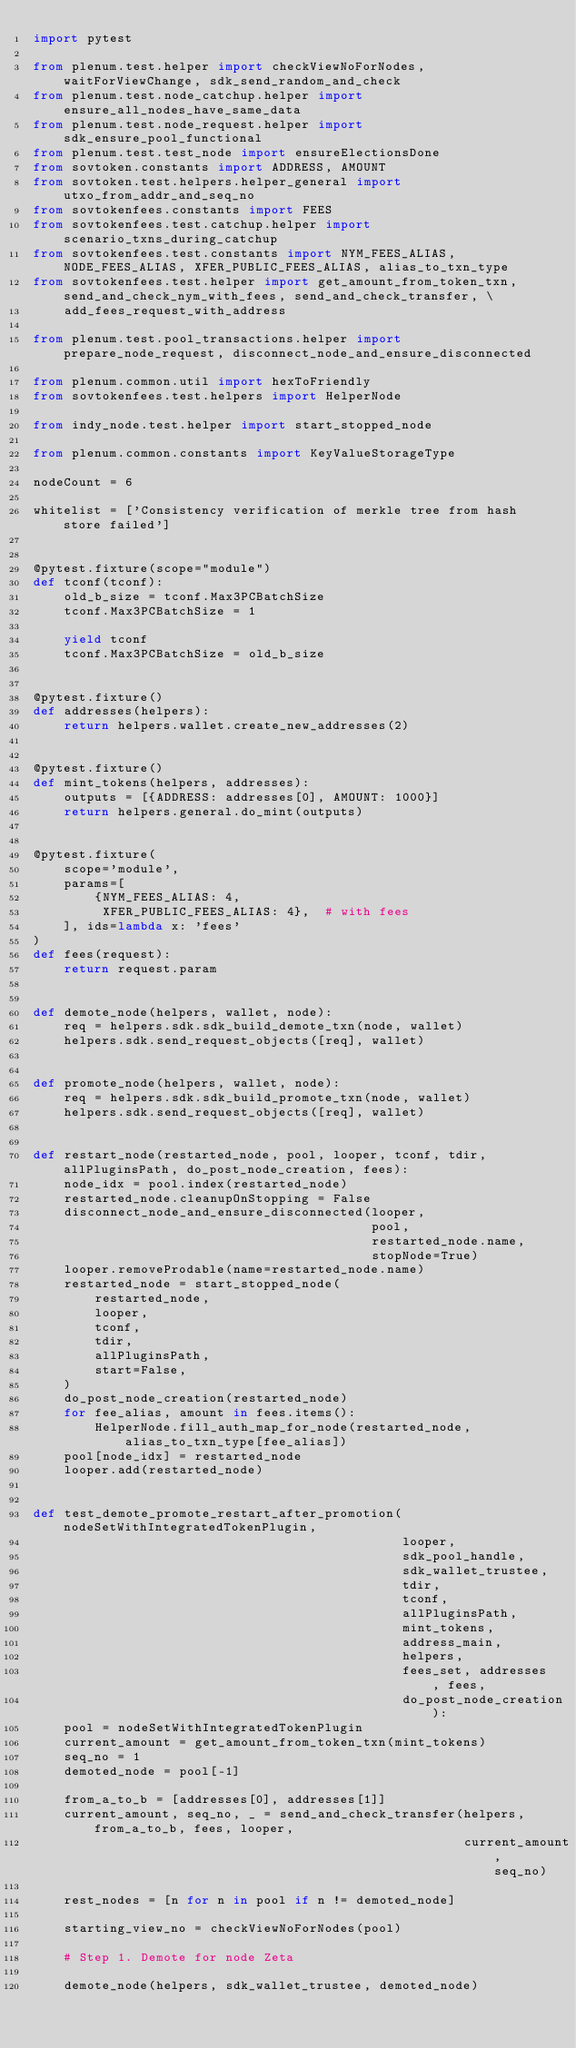<code> <loc_0><loc_0><loc_500><loc_500><_Python_>import pytest

from plenum.test.helper import checkViewNoForNodes, waitForViewChange, sdk_send_random_and_check
from plenum.test.node_catchup.helper import ensure_all_nodes_have_same_data
from plenum.test.node_request.helper import sdk_ensure_pool_functional
from plenum.test.test_node import ensureElectionsDone
from sovtoken.constants import ADDRESS, AMOUNT
from sovtoken.test.helpers.helper_general import utxo_from_addr_and_seq_no
from sovtokenfees.constants import FEES
from sovtokenfees.test.catchup.helper import scenario_txns_during_catchup
from sovtokenfees.test.constants import NYM_FEES_ALIAS, NODE_FEES_ALIAS, XFER_PUBLIC_FEES_ALIAS, alias_to_txn_type
from sovtokenfees.test.helper import get_amount_from_token_txn, send_and_check_nym_with_fees, send_and_check_transfer, \
    add_fees_request_with_address

from plenum.test.pool_transactions.helper import prepare_node_request, disconnect_node_and_ensure_disconnected

from plenum.common.util import hexToFriendly
from sovtokenfees.test.helpers import HelperNode

from indy_node.test.helper import start_stopped_node

from plenum.common.constants import KeyValueStorageType

nodeCount = 6

whitelist = ['Consistency verification of merkle tree from hash store failed']


@pytest.fixture(scope="module")
def tconf(tconf):
    old_b_size = tconf.Max3PCBatchSize
    tconf.Max3PCBatchSize = 1

    yield tconf
    tconf.Max3PCBatchSize = old_b_size


@pytest.fixture()
def addresses(helpers):
    return helpers.wallet.create_new_addresses(2)


@pytest.fixture()
def mint_tokens(helpers, addresses):
    outputs = [{ADDRESS: addresses[0], AMOUNT: 1000}]
    return helpers.general.do_mint(outputs)


@pytest.fixture(
    scope='module',
    params=[
        {NYM_FEES_ALIAS: 4,
         XFER_PUBLIC_FEES_ALIAS: 4},  # with fees
    ], ids=lambda x: 'fees'
)
def fees(request):
    return request.param


def demote_node(helpers, wallet, node):
    req = helpers.sdk.sdk_build_demote_txn(node, wallet)
    helpers.sdk.send_request_objects([req], wallet)


def promote_node(helpers, wallet, node):
    req = helpers.sdk.sdk_build_promote_txn(node, wallet)
    helpers.sdk.send_request_objects([req], wallet)


def restart_node(restarted_node, pool, looper, tconf, tdir, allPluginsPath, do_post_node_creation, fees):
    node_idx = pool.index(restarted_node)
    restarted_node.cleanupOnStopping = False
    disconnect_node_and_ensure_disconnected(looper,
                                            pool,
                                            restarted_node.name,
                                            stopNode=True)
    looper.removeProdable(name=restarted_node.name)
    restarted_node = start_stopped_node(
        restarted_node,
        looper,
        tconf,
        tdir,
        allPluginsPath,
        start=False,
    )
    do_post_node_creation(restarted_node)
    for fee_alias, amount in fees.items():
        HelperNode.fill_auth_map_for_node(restarted_node, alias_to_txn_type[fee_alias])
    pool[node_idx] = restarted_node
    looper.add(restarted_node)


def test_demote_promote_restart_after_promotion(nodeSetWithIntegratedTokenPlugin,
                                                looper,
                                                sdk_pool_handle,
                                                sdk_wallet_trustee,
                                                tdir,
                                                tconf,
                                                allPluginsPath,
                                                mint_tokens,
                                                address_main,
                                                helpers,
                                                fees_set, addresses, fees,
                                                do_post_node_creation):
    pool = nodeSetWithIntegratedTokenPlugin
    current_amount = get_amount_from_token_txn(mint_tokens)
    seq_no = 1
    demoted_node = pool[-1]

    from_a_to_b = [addresses[0], addresses[1]]
    current_amount, seq_no, _ = send_and_check_transfer(helpers, from_a_to_b, fees, looper,
                                                        current_amount, seq_no)

    rest_nodes = [n for n in pool if n != demoted_node]

    starting_view_no = checkViewNoForNodes(pool)

    # Step 1. Demote for node Zeta

    demote_node(helpers, sdk_wallet_trustee, demoted_node)
</code> 